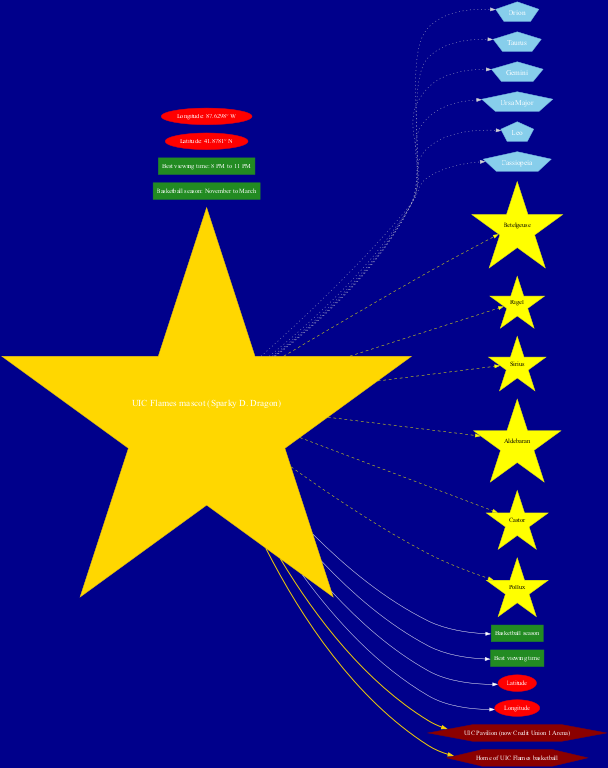What is the center of the star chart? The center of the star chart is labeled as "UIC Flames mascot (Sparky D. Dragon)." There is a specific node in the diagram that highlights this information, clearly indicating its importance as the focal point.
Answer: UIC Flames mascot (Sparky D. Dragon) How many constellations are shown in the diagram? The diagram includes six constellations from the list provided. By counting each constellation node connected to the center, we can confirm the total.
Answer: 6 What star is closest in proximity to Orion in the diagram? The diagram has a connection between the center (UIC Flames mascot) and the constellation Orion. Among the stars listed, Betelgeuse, which is part of Orion, is the closest star visually indicated in the diagram.
Answer: Betelgeuse Which color represents the constellations in the chart? The diagram uses sky blue to represent the constellations. This is indicated by the node attributes for the constellations section of the diagram, specifying their color as sky blue.
Answer: Sky blue What is the best viewing time for the constellations? There is a specific rectangle node detailing that the best viewing time for the constellations is from 8 PM to 11 PM, as stated in the season information section.
Answer: 8 PM to 11 PM How many stars are listed in the chart? Similar to constellations, the diagram lists a total of six stars. By examining the star nodes connected to the center, we find the complete count.
Answer: 6 Which constellation is associated with the star Sirius? The diagram implies that the star Sirius is linked to the constellation Canis Major, but since it likely isn't explicitly shown here, we are led to reason that Sirius is among the notable stars we could identify. It’s essential to see how it connects in the wider context of constellations.
Answer: Canis Major What shape represents the UIC connection? The UIC connection nodes are represented as hexagons in the diagram, clearly distinguishing them from other types of nodes. The attributes in the diagram confirm their unique shape and color.
Answer: Hexagon 